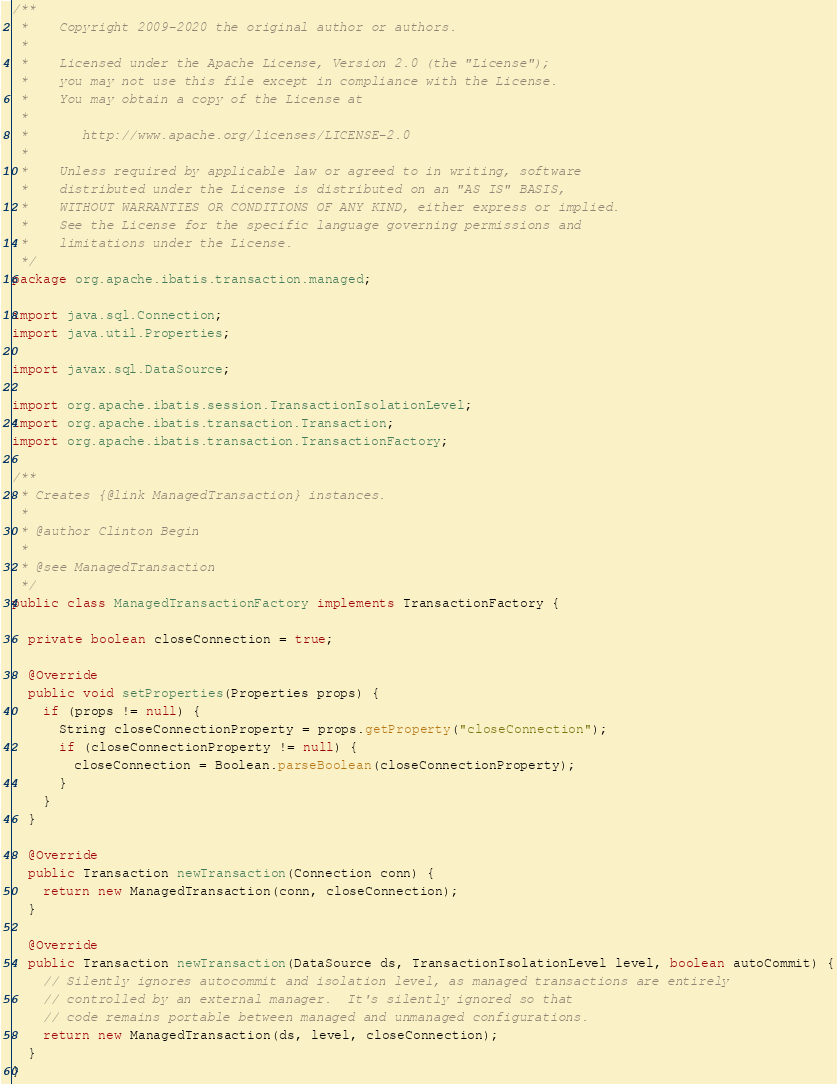Convert code to text. <code><loc_0><loc_0><loc_500><loc_500><_Java_>/**
 *    Copyright 2009-2020 the original author or authors.
 *
 *    Licensed under the Apache License, Version 2.0 (the "License");
 *    you may not use this file except in compliance with the License.
 *    You may obtain a copy of the License at
 *
 *       http://www.apache.org/licenses/LICENSE-2.0
 *
 *    Unless required by applicable law or agreed to in writing, software
 *    distributed under the License is distributed on an "AS IS" BASIS,
 *    WITHOUT WARRANTIES OR CONDITIONS OF ANY KIND, either express or implied.
 *    See the License for the specific language governing permissions and
 *    limitations under the License.
 */
package org.apache.ibatis.transaction.managed;

import java.sql.Connection;
import java.util.Properties;

import javax.sql.DataSource;

import org.apache.ibatis.session.TransactionIsolationLevel;
import org.apache.ibatis.transaction.Transaction;
import org.apache.ibatis.transaction.TransactionFactory;

/**
 * Creates {@link ManagedTransaction} instances.
 *
 * @author Clinton Begin
 *
 * @see ManagedTransaction
 */
public class ManagedTransactionFactory implements TransactionFactory {

  private boolean closeConnection = true;

  @Override
  public void setProperties(Properties props) {
    if (props != null) {
      String closeConnectionProperty = props.getProperty("closeConnection");
      if (closeConnectionProperty != null) {
        closeConnection = Boolean.parseBoolean(closeConnectionProperty);
      }
    }
  }

  @Override
  public Transaction newTransaction(Connection conn) {
    return new ManagedTransaction(conn, closeConnection);
  }

  @Override
  public Transaction newTransaction(DataSource ds, TransactionIsolationLevel level, boolean autoCommit) {
    // Silently ignores autocommit and isolation level, as managed transactions are entirely
    // controlled by an external manager.  It's silently ignored so that
    // code remains portable between managed and unmanaged configurations.
    return new ManagedTransaction(ds, level, closeConnection);
  }
}
</code> 